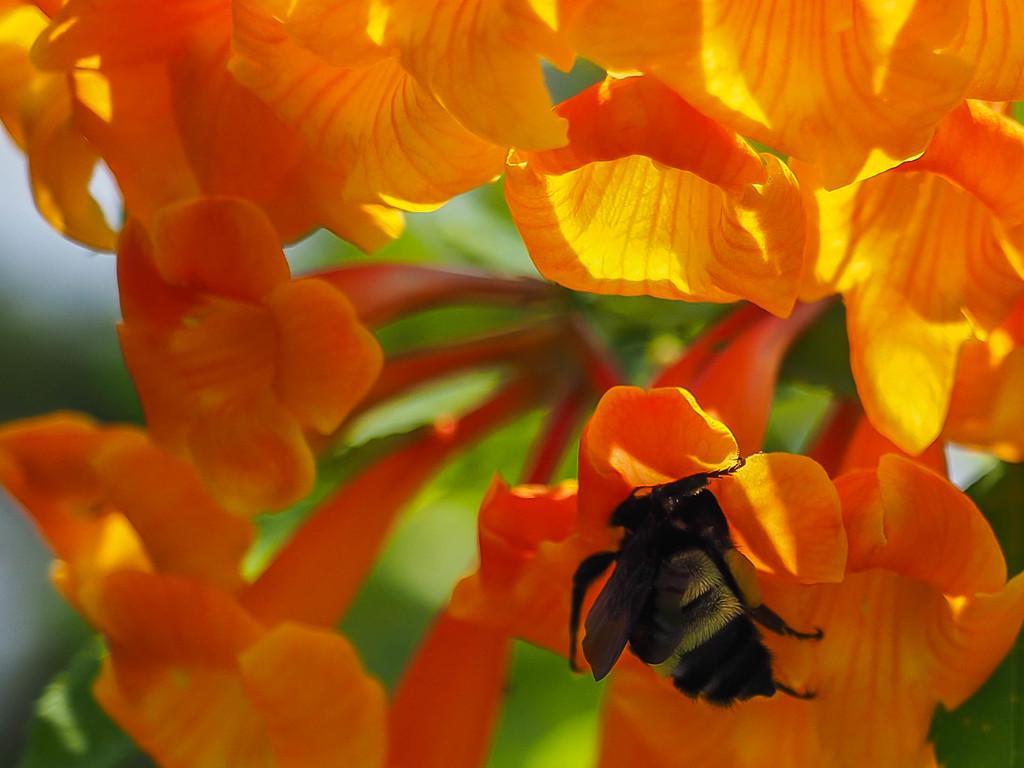In one or two sentences, can you explain what this image depicts? This image consists of flowers in orange color. And we can see a bee on the flower. In the background, there are green leaves. 